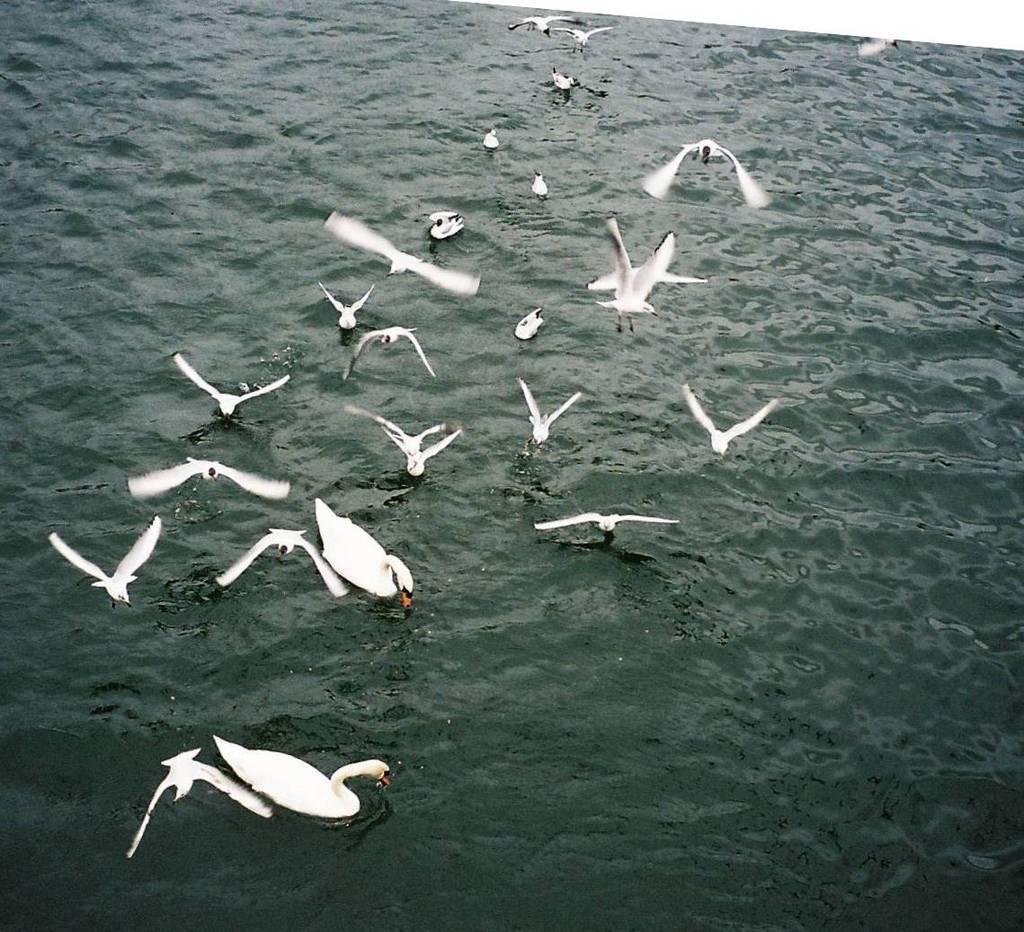What type of animals are present in the image? There are many ducks and birds in the image. Where are the ducks and birds located? The ducks and birds are on the water. Are there any birds in the image that are not on the water? Yes, some birds are flying in the air. How many legs does the scarecrow have in the image? There is no scarecrow present in the image, so it is not possible to determine the number of legs it might have. 